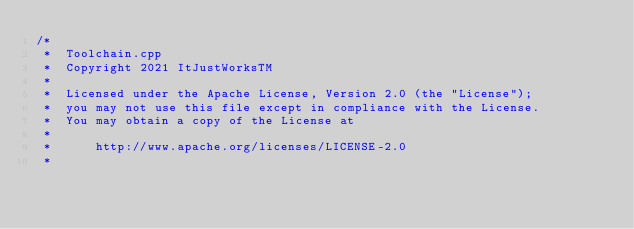Convert code to text. <code><loc_0><loc_0><loc_500><loc_500><_C++_>/*
 *  Toolchain.cpp
 *  Copyright 2021 ItJustWorksTM
 *
 *  Licensed under the Apache License, Version 2.0 (the "License");
 *  you may not use this file except in compliance with the License.
 *  You may obtain a copy of the License at
 *
 *      http://www.apache.org/licenses/LICENSE-2.0
 *</code> 